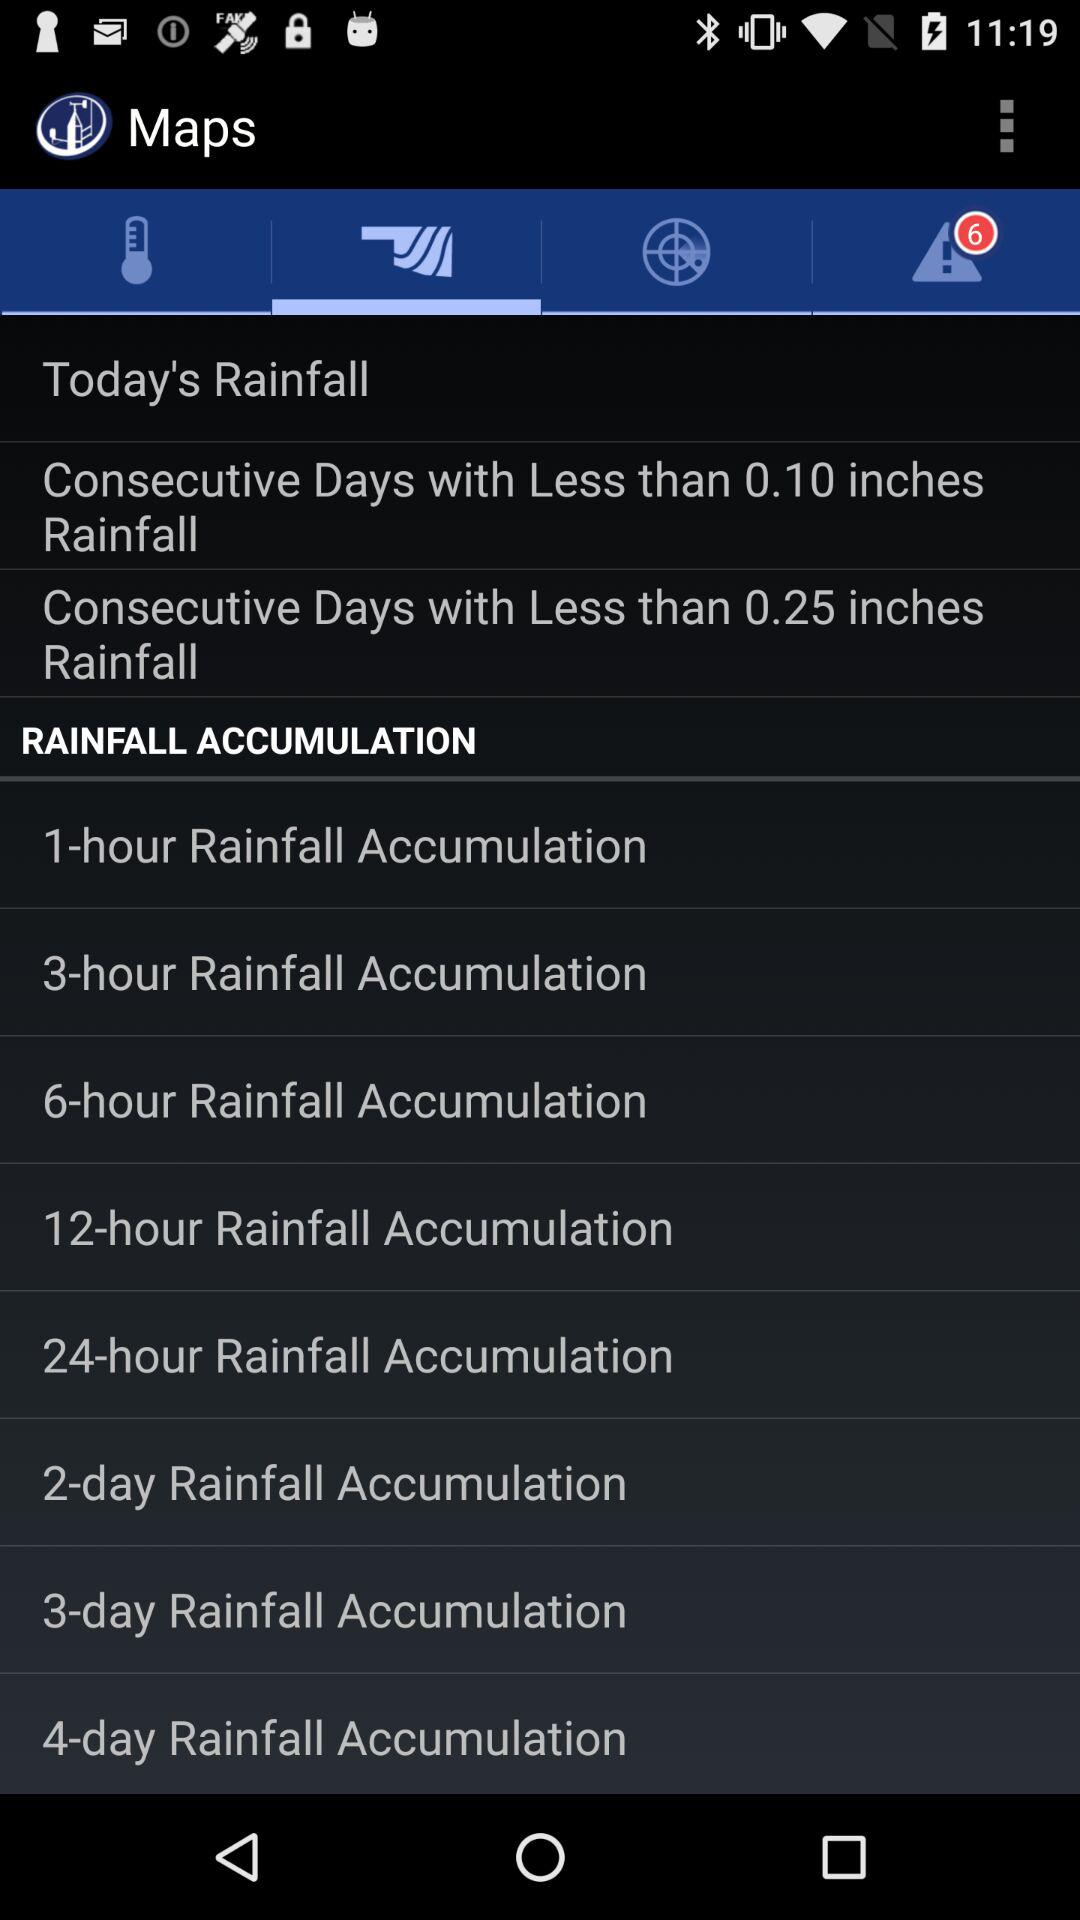How many new alert notifications are there? There are 6 notifications. 